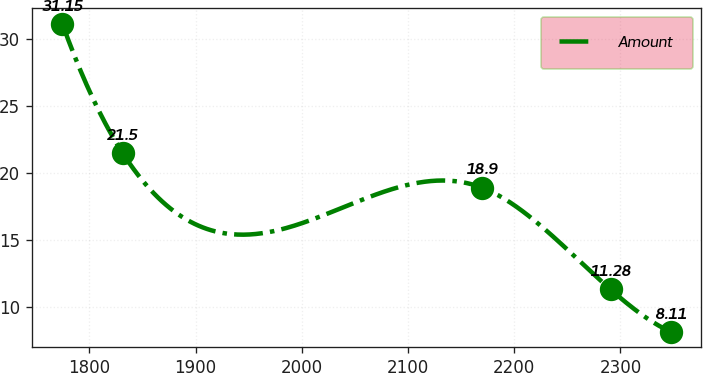<chart> <loc_0><loc_0><loc_500><loc_500><line_chart><ecel><fcel>Amount<nl><fcel>1774.61<fcel>31.15<nl><fcel>1831.25<fcel>21.5<nl><fcel>2169.64<fcel>18.9<nl><fcel>2290.8<fcel>11.28<nl><fcel>2347.44<fcel>8.11<nl></chart> 